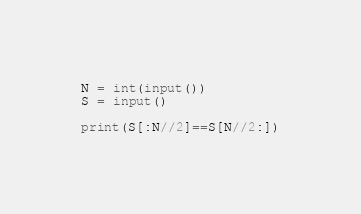<code> <loc_0><loc_0><loc_500><loc_500><_Python_>N = int(input())
S = input()

print(S[:N//2]==S[N//2:])</code> 